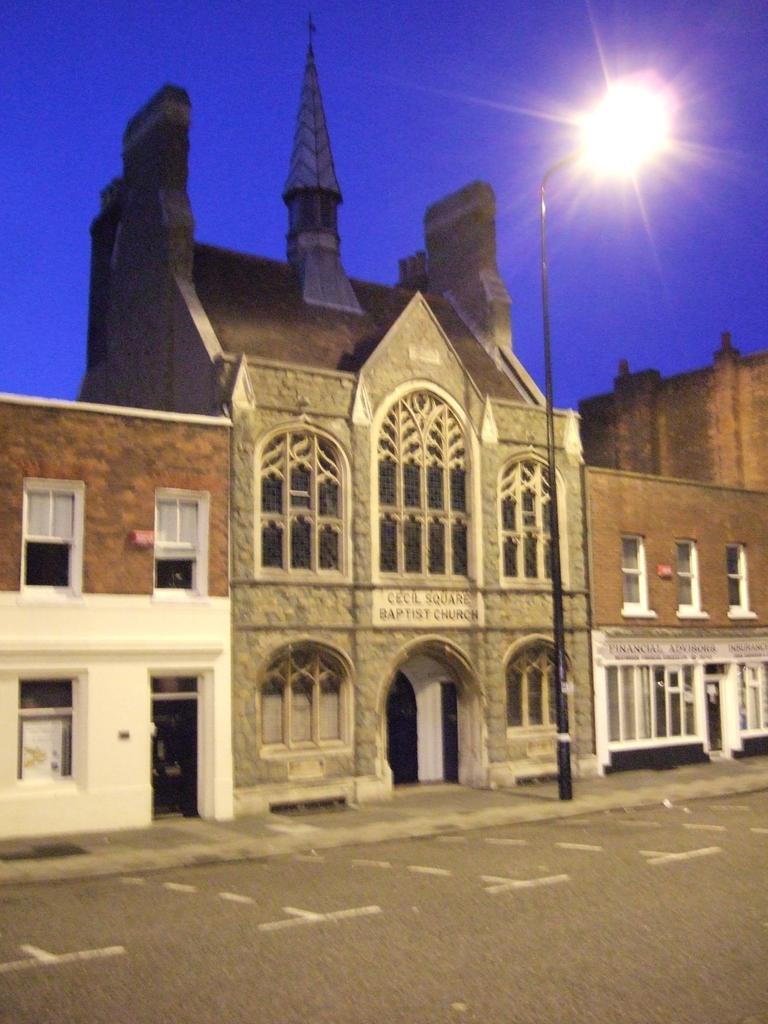In one or two sentences, can you explain what this image depicts? In this image we can see a building with windows and a sign board with some text on it. We can also see a street pole, the pathway and the sky. 